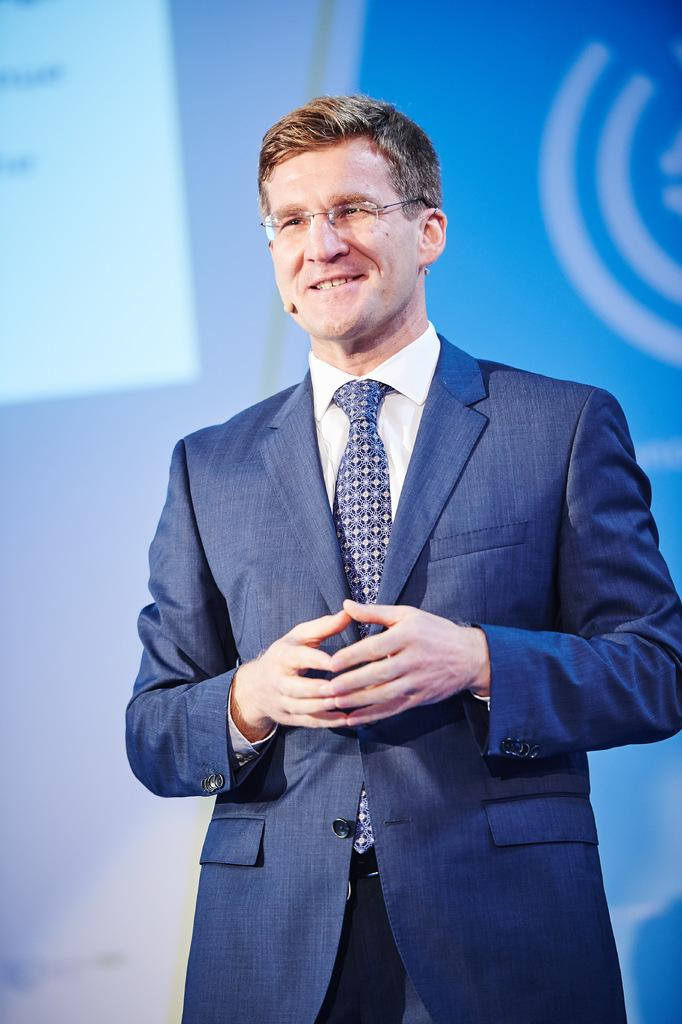What is the main subject of the image? The main subject of the image is a man. What can be seen on the man's face? The man is wearing spectacles. What is the man holding in the image? The man is holding a mic. What type of clothing is the man wearing? The man is wearing a suit and trousers. What is visible in the background of the image? There is a projector screen in the background of the image. What type of nut is the man cracking in the image? There is no nut present in the image; the man is holding a mic. How far does the range of the projector screen extend in the image? The range of the projector screen is not visible or measurable in the image; it only shows the screen itself. 